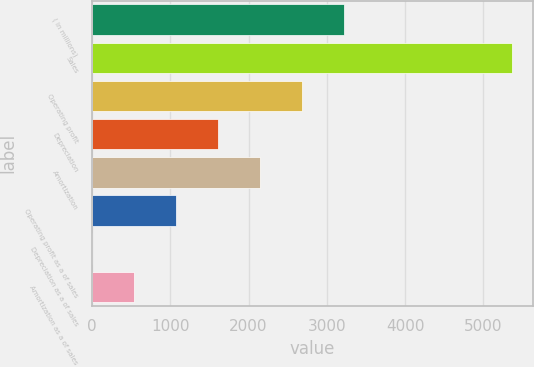<chart> <loc_0><loc_0><loc_500><loc_500><bar_chart><fcel>( in millions)<fcel>Sales<fcel>Operating profit<fcel>Depreciation<fcel>Amortization<fcel>Operating profit as a of sales<fcel>Depreciation as a of sales<fcel>Amortization as a of sales<nl><fcel>3220.5<fcel>5365.9<fcel>2684.15<fcel>1611.45<fcel>2147.8<fcel>1075.1<fcel>2.4<fcel>538.75<nl></chart> 